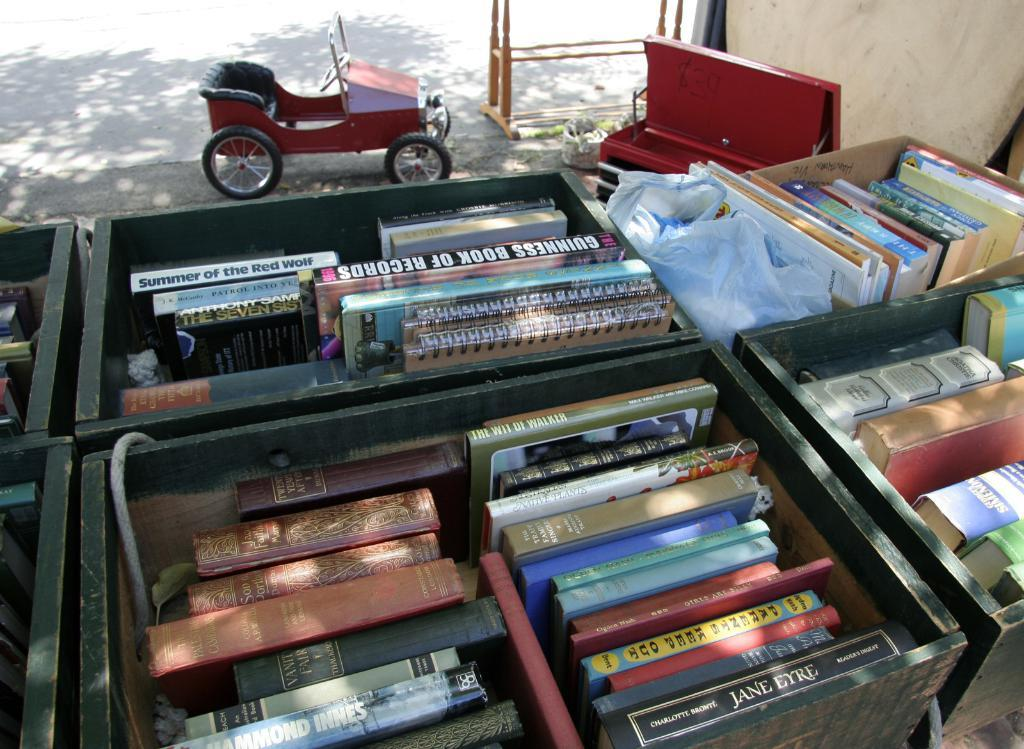What objects are present in the image? There are books in the image, and they are in boxes. Can you describe the books in the image? The books are in multiple colors. What can be seen in the background of the image? There is a red vehicle in the background of the image. What type of object is made of wood in the image? There is a wooden object in the image. How many icicles are hanging from the books in the image? There are no icicles present in the image; it features books in boxes. What type of division is being taught using the books in the image? There is no indication of any division being taught in the image; it simply shows books in boxes. 